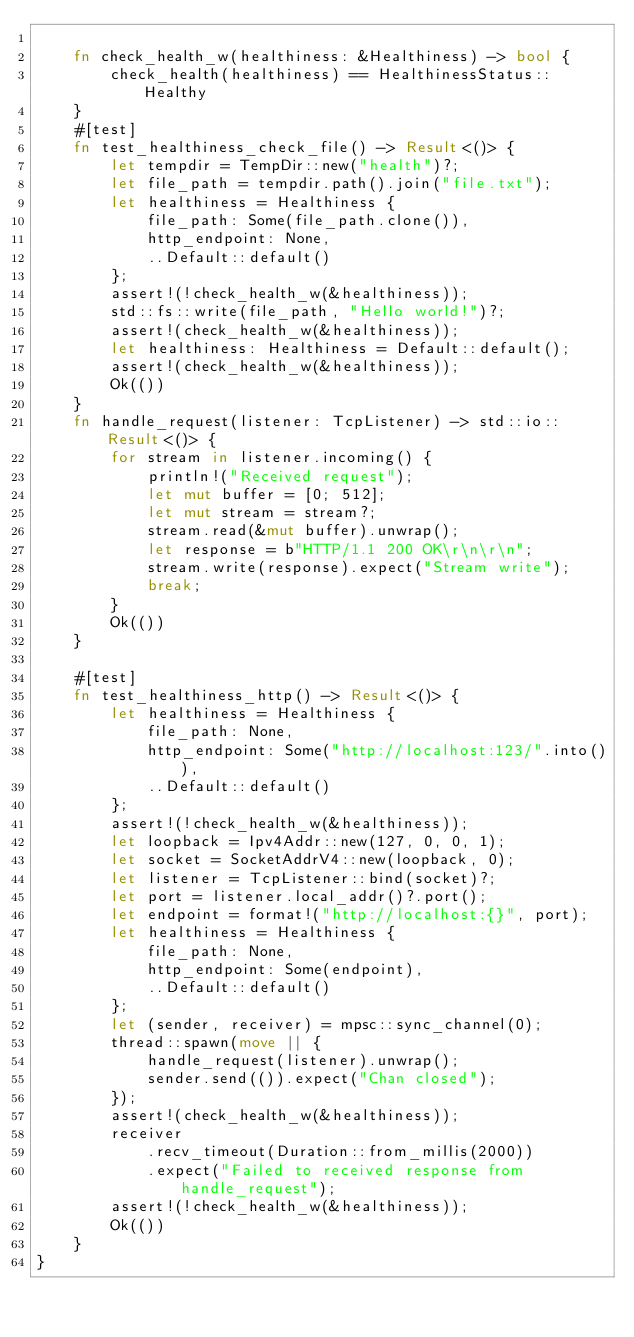Convert code to text. <code><loc_0><loc_0><loc_500><loc_500><_Rust_>
    fn check_health_w(healthiness: &Healthiness) -> bool {
        check_health(healthiness) == HealthinessStatus::Healthy
    }
    #[test]
    fn test_healthiness_check_file() -> Result<()> {
        let tempdir = TempDir::new("health")?;
        let file_path = tempdir.path().join("file.txt");
        let healthiness = Healthiness {
            file_path: Some(file_path.clone()),
            http_endpoint: None,
            ..Default::default()
        };
        assert!(!check_health_w(&healthiness));
        std::fs::write(file_path, "Hello world!")?;
        assert!(check_health_w(&healthiness));
        let healthiness: Healthiness = Default::default();
        assert!(check_health_w(&healthiness));
        Ok(())
    }
    fn handle_request(listener: TcpListener) -> std::io::Result<()> {
        for stream in listener.incoming() {
            println!("Received request");
            let mut buffer = [0; 512];
            let mut stream = stream?;
            stream.read(&mut buffer).unwrap();
            let response = b"HTTP/1.1 200 OK\r\n\r\n";
            stream.write(response).expect("Stream write");
            break;
        }
        Ok(())
    }

    #[test]
    fn test_healthiness_http() -> Result<()> {
        let healthiness = Healthiness {
            file_path: None,
            http_endpoint: Some("http://localhost:123/".into()),
            ..Default::default()
        };
        assert!(!check_health_w(&healthiness));
        let loopback = Ipv4Addr::new(127, 0, 0, 1);
        let socket = SocketAddrV4::new(loopback, 0);
        let listener = TcpListener::bind(socket)?;
        let port = listener.local_addr()?.port();
        let endpoint = format!("http://localhost:{}", port);
        let healthiness = Healthiness {
            file_path: None,
            http_endpoint: Some(endpoint),
            ..Default::default()
        };
        let (sender, receiver) = mpsc::sync_channel(0);
        thread::spawn(move || {
            handle_request(listener).unwrap();
            sender.send(()).expect("Chan closed");
        });
        assert!(check_health_w(&healthiness));
        receiver
            .recv_timeout(Duration::from_millis(2000))
            .expect("Failed to received response from handle_request");
        assert!(!check_health_w(&healthiness));
        Ok(())
    }
}
</code> 